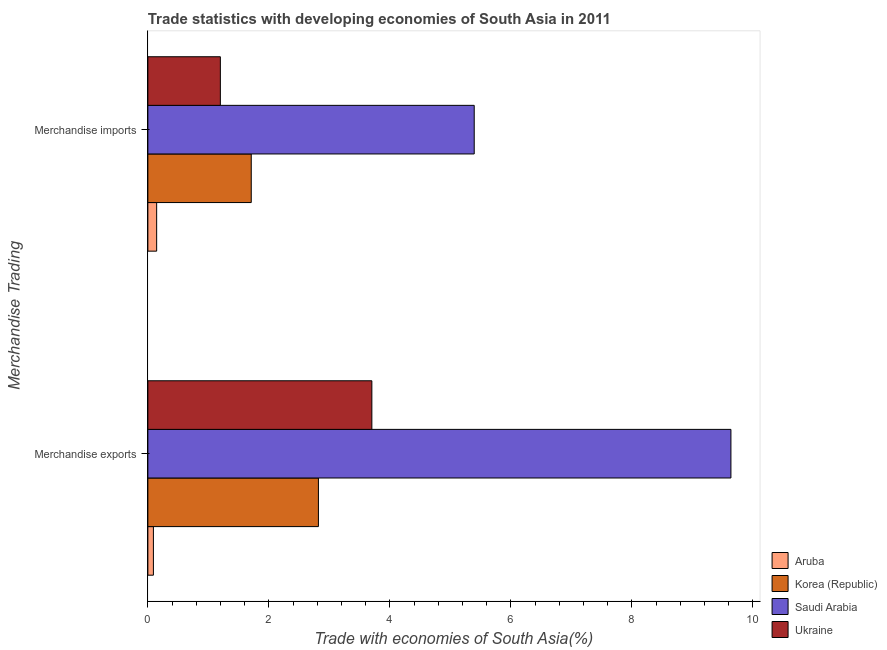Are the number of bars per tick equal to the number of legend labels?
Offer a terse response. Yes. Are the number of bars on each tick of the Y-axis equal?
Your answer should be very brief. Yes. How many bars are there on the 2nd tick from the bottom?
Give a very brief answer. 4. What is the label of the 1st group of bars from the top?
Offer a very short reply. Merchandise imports. What is the merchandise imports in Aruba?
Provide a short and direct response. 0.15. Across all countries, what is the maximum merchandise imports?
Make the answer very short. 5.39. Across all countries, what is the minimum merchandise exports?
Provide a succinct answer. 0.09. In which country was the merchandise exports maximum?
Keep it short and to the point. Saudi Arabia. In which country was the merchandise imports minimum?
Your answer should be compact. Aruba. What is the total merchandise exports in the graph?
Make the answer very short. 16.25. What is the difference between the merchandise imports in Ukraine and that in Saudi Arabia?
Make the answer very short. -4.2. What is the difference between the merchandise exports in Aruba and the merchandise imports in Korea (Republic)?
Provide a succinct answer. -1.62. What is the average merchandise imports per country?
Your answer should be compact. 2.11. What is the difference between the merchandise exports and merchandise imports in Ukraine?
Make the answer very short. 2.5. In how many countries, is the merchandise imports greater than 8.8 %?
Your answer should be very brief. 0. What is the ratio of the merchandise imports in Korea (Republic) to that in Saudi Arabia?
Keep it short and to the point. 0.32. What does the 2nd bar from the top in Merchandise imports represents?
Ensure brevity in your answer.  Saudi Arabia. What does the 1st bar from the bottom in Merchandise exports represents?
Your answer should be compact. Aruba. How many countries are there in the graph?
Your answer should be compact. 4. Does the graph contain grids?
Keep it short and to the point. No. Where does the legend appear in the graph?
Provide a succinct answer. Bottom right. How are the legend labels stacked?
Offer a very short reply. Vertical. What is the title of the graph?
Ensure brevity in your answer.  Trade statistics with developing economies of South Asia in 2011. What is the label or title of the X-axis?
Give a very brief answer. Trade with economies of South Asia(%). What is the label or title of the Y-axis?
Provide a short and direct response. Merchandise Trading. What is the Trade with economies of South Asia(%) of Aruba in Merchandise exports?
Keep it short and to the point. 0.09. What is the Trade with economies of South Asia(%) of Korea (Republic) in Merchandise exports?
Make the answer very short. 2.82. What is the Trade with economies of South Asia(%) of Saudi Arabia in Merchandise exports?
Ensure brevity in your answer.  9.64. What is the Trade with economies of South Asia(%) in Ukraine in Merchandise exports?
Your answer should be compact. 3.7. What is the Trade with economies of South Asia(%) in Aruba in Merchandise imports?
Offer a terse response. 0.15. What is the Trade with economies of South Asia(%) of Korea (Republic) in Merchandise imports?
Provide a succinct answer. 1.71. What is the Trade with economies of South Asia(%) in Saudi Arabia in Merchandise imports?
Provide a succinct answer. 5.39. What is the Trade with economies of South Asia(%) in Ukraine in Merchandise imports?
Make the answer very short. 1.2. Across all Merchandise Trading, what is the maximum Trade with economies of South Asia(%) in Aruba?
Provide a succinct answer. 0.15. Across all Merchandise Trading, what is the maximum Trade with economies of South Asia(%) in Korea (Republic)?
Make the answer very short. 2.82. Across all Merchandise Trading, what is the maximum Trade with economies of South Asia(%) of Saudi Arabia?
Provide a short and direct response. 9.64. Across all Merchandise Trading, what is the maximum Trade with economies of South Asia(%) of Ukraine?
Your answer should be very brief. 3.7. Across all Merchandise Trading, what is the minimum Trade with economies of South Asia(%) of Aruba?
Offer a terse response. 0.09. Across all Merchandise Trading, what is the minimum Trade with economies of South Asia(%) in Korea (Republic)?
Provide a succinct answer. 1.71. Across all Merchandise Trading, what is the minimum Trade with economies of South Asia(%) of Saudi Arabia?
Your answer should be very brief. 5.39. Across all Merchandise Trading, what is the minimum Trade with economies of South Asia(%) of Ukraine?
Provide a succinct answer. 1.2. What is the total Trade with economies of South Asia(%) in Aruba in the graph?
Your answer should be compact. 0.24. What is the total Trade with economies of South Asia(%) of Korea (Republic) in the graph?
Ensure brevity in your answer.  4.53. What is the total Trade with economies of South Asia(%) of Saudi Arabia in the graph?
Provide a short and direct response. 15.03. What is the total Trade with economies of South Asia(%) of Ukraine in the graph?
Your response must be concise. 4.9. What is the difference between the Trade with economies of South Asia(%) in Aruba in Merchandise exports and that in Merchandise imports?
Make the answer very short. -0.05. What is the difference between the Trade with economies of South Asia(%) of Korea (Republic) in Merchandise exports and that in Merchandise imports?
Offer a terse response. 1.11. What is the difference between the Trade with economies of South Asia(%) in Saudi Arabia in Merchandise exports and that in Merchandise imports?
Offer a terse response. 4.24. What is the difference between the Trade with economies of South Asia(%) in Ukraine in Merchandise exports and that in Merchandise imports?
Your answer should be compact. 2.5. What is the difference between the Trade with economies of South Asia(%) in Aruba in Merchandise exports and the Trade with economies of South Asia(%) in Korea (Republic) in Merchandise imports?
Give a very brief answer. -1.62. What is the difference between the Trade with economies of South Asia(%) of Aruba in Merchandise exports and the Trade with economies of South Asia(%) of Saudi Arabia in Merchandise imports?
Provide a short and direct response. -5.3. What is the difference between the Trade with economies of South Asia(%) of Aruba in Merchandise exports and the Trade with economies of South Asia(%) of Ukraine in Merchandise imports?
Make the answer very short. -1.11. What is the difference between the Trade with economies of South Asia(%) of Korea (Republic) in Merchandise exports and the Trade with economies of South Asia(%) of Saudi Arabia in Merchandise imports?
Your answer should be compact. -2.57. What is the difference between the Trade with economies of South Asia(%) in Korea (Republic) in Merchandise exports and the Trade with economies of South Asia(%) in Ukraine in Merchandise imports?
Provide a succinct answer. 1.62. What is the difference between the Trade with economies of South Asia(%) of Saudi Arabia in Merchandise exports and the Trade with economies of South Asia(%) of Ukraine in Merchandise imports?
Give a very brief answer. 8.44. What is the average Trade with economies of South Asia(%) of Aruba per Merchandise Trading?
Offer a terse response. 0.12. What is the average Trade with economies of South Asia(%) in Korea (Republic) per Merchandise Trading?
Provide a short and direct response. 2.26. What is the average Trade with economies of South Asia(%) of Saudi Arabia per Merchandise Trading?
Provide a short and direct response. 7.51. What is the average Trade with economies of South Asia(%) of Ukraine per Merchandise Trading?
Provide a succinct answer. 2.45. What is the difference between the Trade with economies of South Asia(%) of Aruba and Trade with economies of South Asia(%) of Korea (Republic) in Merchandise exports?
Offer a very short reply. -2.73. What is the difference between the Trade with economies of South Asia(%) in Aruba and Trade with economies of South Asia(%) in Saudi Arabia in Merchandise exports?
Keep it short and to the point. -9.54. What is the difference between the Trade with economies of South Asia(%) of Aruba and Trade with economies of South Asia(%) of Ukraine in Merchandise exports?
Ensure brevity in your answer.  -3.61. What is the difference between the Trade with economies of South Asia(%) of Korea (Republic) and Trade with economies of South Asia(%) of Saudi Arabia in Merchandise exports?
Provide a succinct answer. -6.82. What is the difference between the Trade with economies of South Asia(%) of Korea (Republic) and Trade with economies of South Asia(%) of Ukraine in Merchandise exports?
Make the answer very short. -0.88. What is the difference between the Trade with economies of South Asia(%) in Saudi Arabia and Trade with economies of South Asia(%) in Ukraine in Merchandise exports?
Your response must be concise. 5.93. What is the difference between the Trade with economies of South Asia(%) of Aruba and Trade with economies of South Asia(%) of Korea (Republic) in Merchandise imports?
Keep it short and to the point. -1.56. What is the difference between the Trade with economies of South Asia(%) of Aruba and Trade with economies of South Asia(%) of Saudi Arabia in Merchandise imports?
Give a very brief answer. -5.25. What is the difference between the Trade with economies of South Asia(%) of Aruba and Trade with economies of South Asia(%) of Ukraine in Merchandise imports?
Your answer should be very brief. -1.05. What is the difference between the Trade with economies of South Asia(%) in Korea (Republic) and Trade with economies of South Asia(%) in Saudi Arabia in Merchandise imports?
Provide a short and direct response. -3.69. What is the difference between the Trade with economies of South Asia(%) of Korea (Republic) and Trade with economies of South Asia(%) of Ukraine in Merchandise imports?
Provide a succinct answer. 0.51. What is the difference between the Trade with economies of South Asia(%) of Saudi Arabia and Trade with economies of South Asia(%) of Ukraine in Merchandise imports?
Give a very brief answer. 4.2. What is the ratio of the Trade with economies of South Asia(%) of Aruba in Merchandise exports to that in Merchandise imports?
Provide a succinct answer. 0.63. What is the ratio of the Trade with economies of South Asia(%) in Korea (Republic) in Merchandise exports to that in Merchandise imports?
Provide a short and direct response. 1.65. What is the ratio of the Trade with economies of South Asia(%) of Saudi Arabia in Merchandise exports to that in Merchandise imports?
Make the answer very short. 1.79. What is the ratio of the Trade with economies of South Asia(%) of Ukraine in Merchandise exports to that in Merchandise imports?
Provide a short and direct response. 3.09. What is the difference between the highest and the second highest Trade with economies of South Asia(%) of Aruba?
Offer a very short reply. 0.05. What is the difference between the highest and the second highest Trade with economies of South Asia(%) of Korea (Republic)?
Your answer should be very brief. 1.11. What is the difference between the highest and the second highest Trade with economies of South Asia(%) of Saudi Arabia?
Give a very brief answer. 4.24. What is the difference between the highest and the second highest Trade with economies of South Asia(%) in Ukraine?
Your answer should be very brief. 2.5. What is the difference between the highest and the lowest Trade with economies of South Asia(%) in Aruba?
Offer a terse response. 0.05. What is the difference between the highest and the lowest Trade with economies of South Asia(%) of Korea (Republic)?
Give a very brief answer. 1.11. What is the difference between the highest and the lowest Trade with economies of South Asia(%) of Saudi Arabia?
Ensure brevity in your answer.  4.24. What is the difference between the highest and the lowest Trade with economies of South Asia(%) in Ukraine?
Make the answer very short. 2.5. 